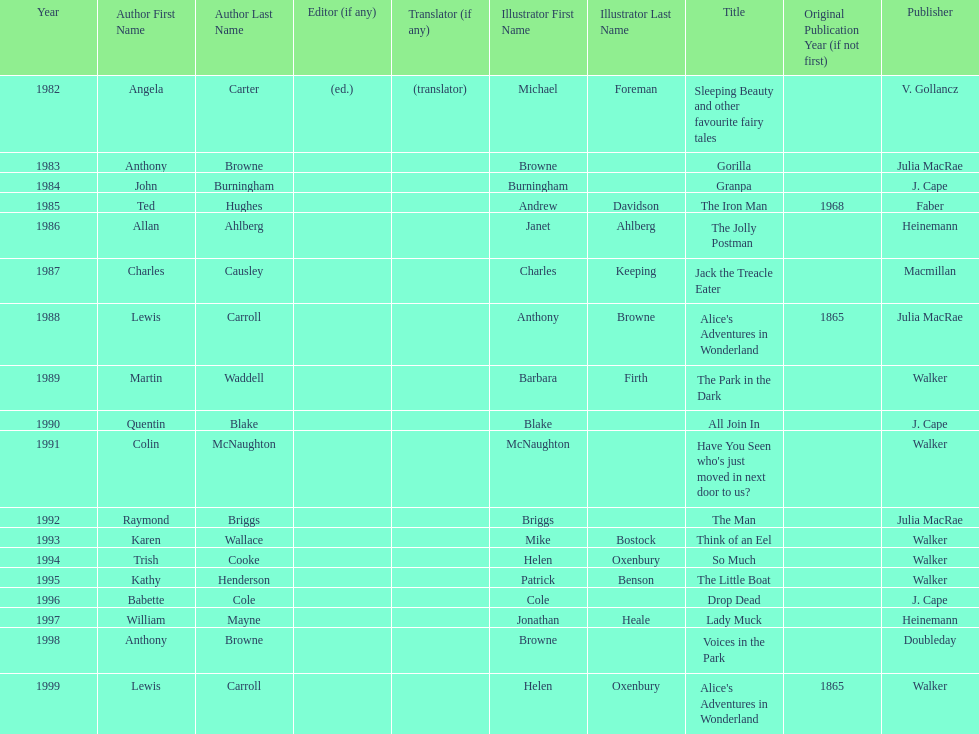Which illustrator was responsible for the last award winner? Helen Oxenbury. 